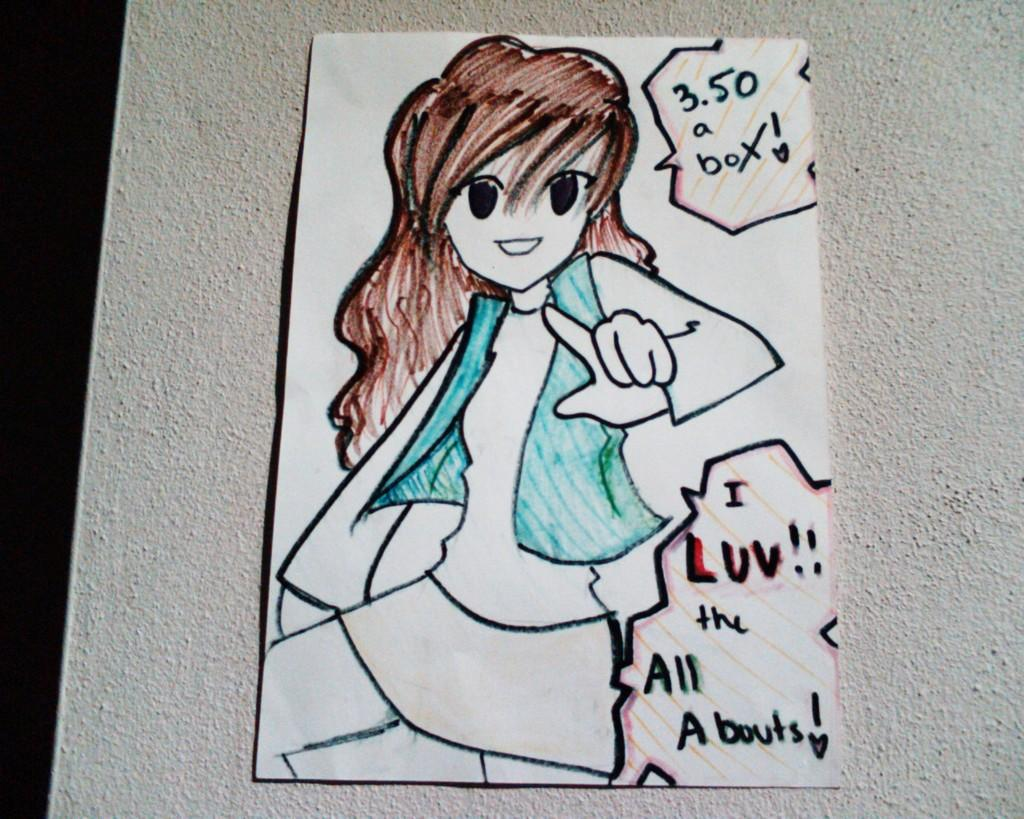What is depicted in the image? There is a drawing of a cartoon in the image. What is the medium of the drawing? The drawing is on a paper. Where is the paper with the drawing located? The paper is pasted on a wall. What else can be found on the paper besides the drawing? There is text on the paper. What type of theory is being discussed at the zoo in the image? There is no zoo or theory present in the image; it features a drawing of a cartoon on a paper pasted on a wall. 